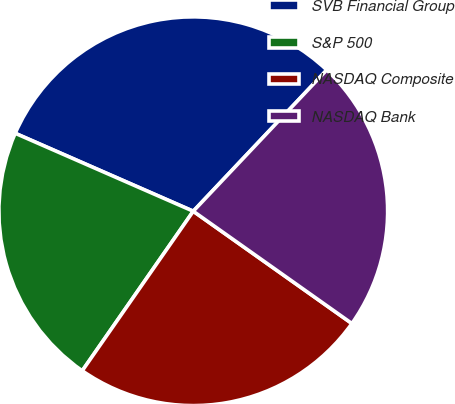<chart> <loc_0><loc_0><loc_500><loc_500><pie_chart><fcel>SVB Financial Group<fcel>S&P 500<fcel>NASDAQ Composite<fcel>NASDAQ Bank<nl><fcel>30.48%<fcel>21.89%<fcel>24.87%<fcel>22.75%<nl></chart> 